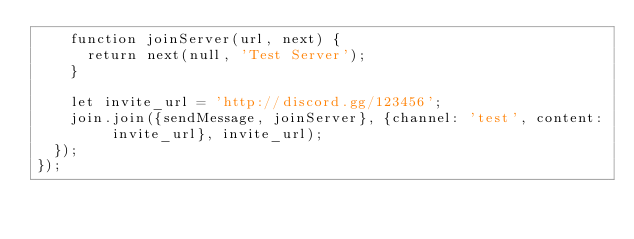<code> <loc_0><loc_0><loc_500><loc_500><_JavaScript_>    function joinServer(url, next) {
      return next(null, 'Test Server');
    }

    let invite_url = 'http://discord.gg/123456';
    join.join({sendMessage, joinServer}, {channel: 'test', content: invite_url}, invite_url);
  });
});
</code> 